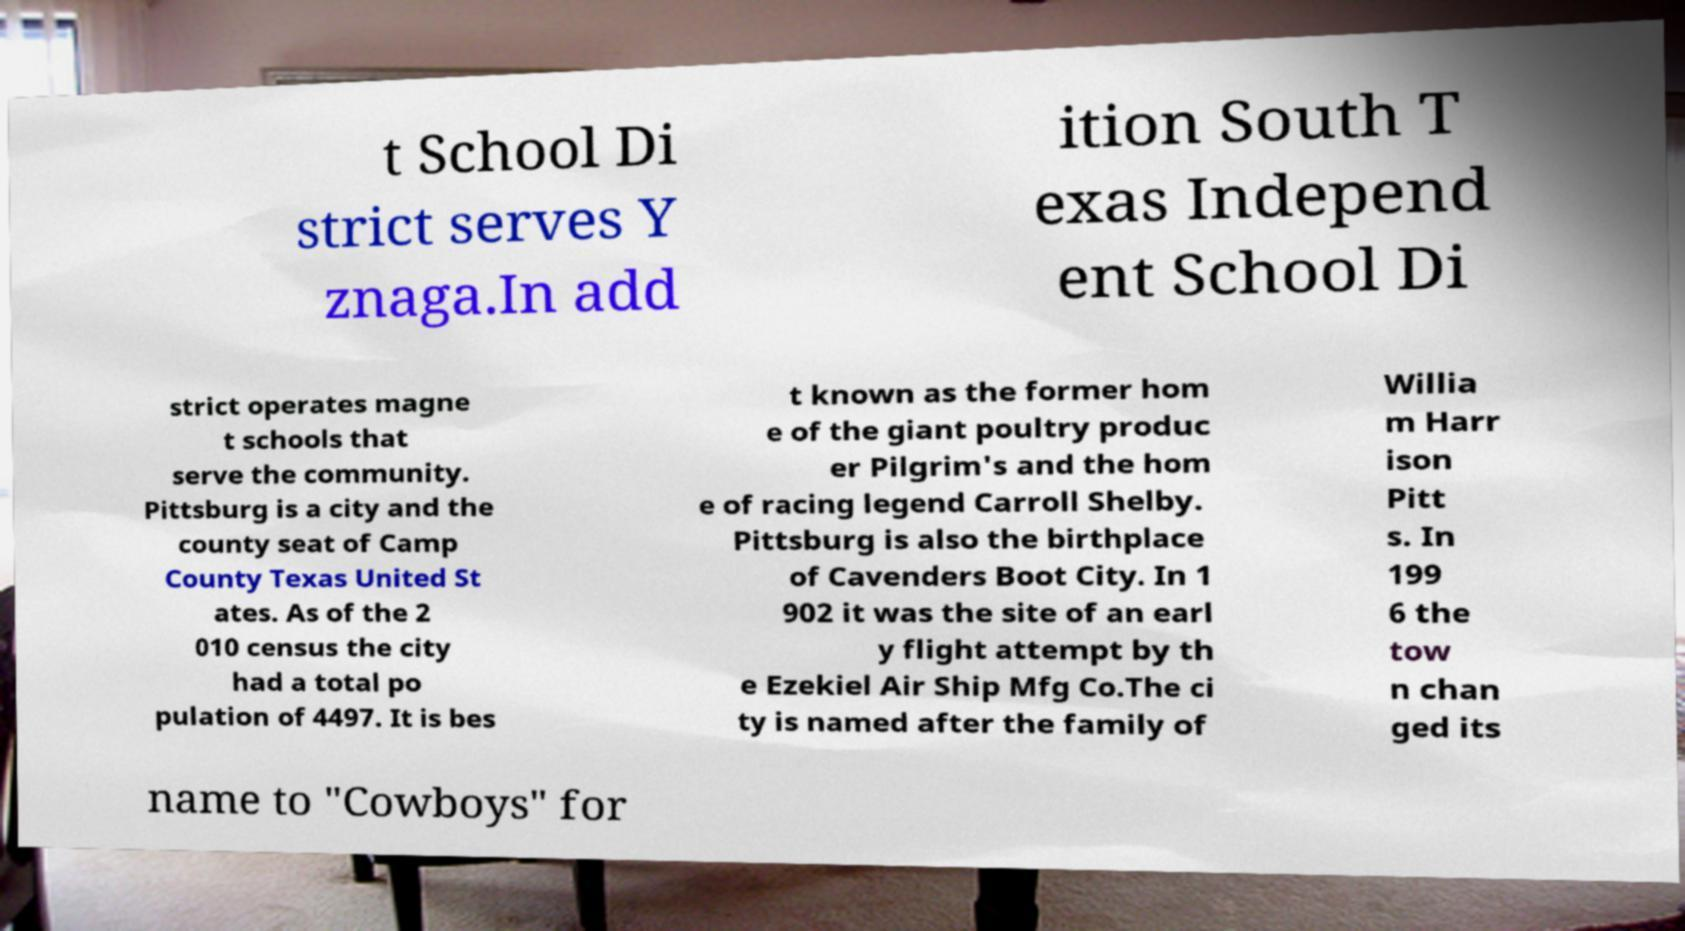Please identify and transcribe the text found in this image. t School Di strict serves Y znaga.In add ition South T exas Independ ent School Di strict operates magne t schools that serve the community. Pittsburg is a city and the county seat of Camp County Texas United St ates. As of the 2 010 census the city had a total po pulation of 4497. It is bes t known as the former hom e of the giant poultry produc er Pilgrim's and the hom e of racing legend Carroll Shelby. Pittsburg is also the birthplace of Cavenders Boot City. In 1 902 it was the site of an earl y flight attempt by th e Ezekiel Air Ship Mfg Co.The ci ty is named after the family of Willia m Harr ison Pitt s. In 199 6 the tow n chan ged its name to "Cowboys" for 